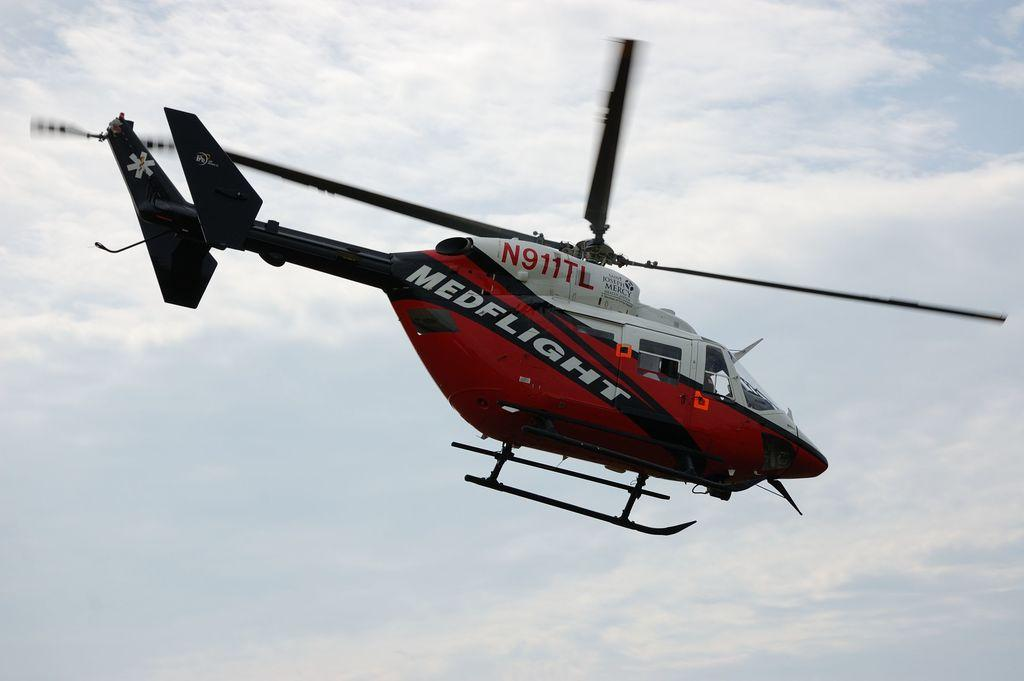Provide a one-sentence caption for the provided image. a red and white helicopter that says medflight on it. 